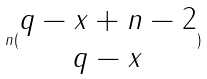<formula> <loc_0><loc_0><loc_500><loc_500>n ( \begin{matrix} q - x + n - 2 \\ q - x \end{matrix} )</formula> 